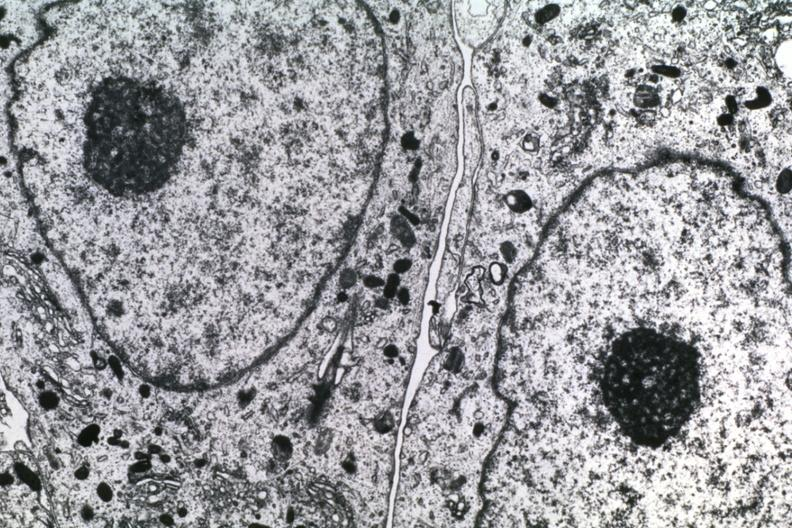what does this image show?
Answer the question using a single word or phrase. Dr garcia tumors 58 